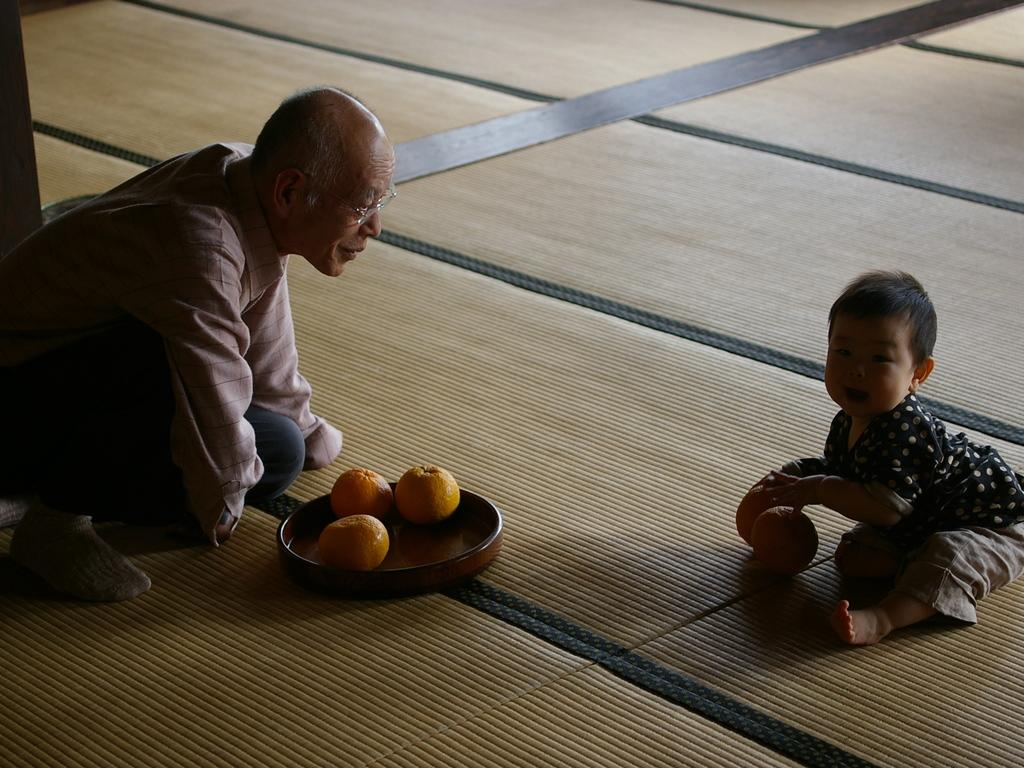Who is in the image? There is a man in the image. What is the man wearing? The man is wearing spectacles. What can be seen on the plate in the image? There is a plate with fruits in the image. What is the child doing in the image? A child is present on the floor in the image. What is the title of the volleyball game being played in the image? There is no volleyball game present in the image, so there is no title to be determined. 